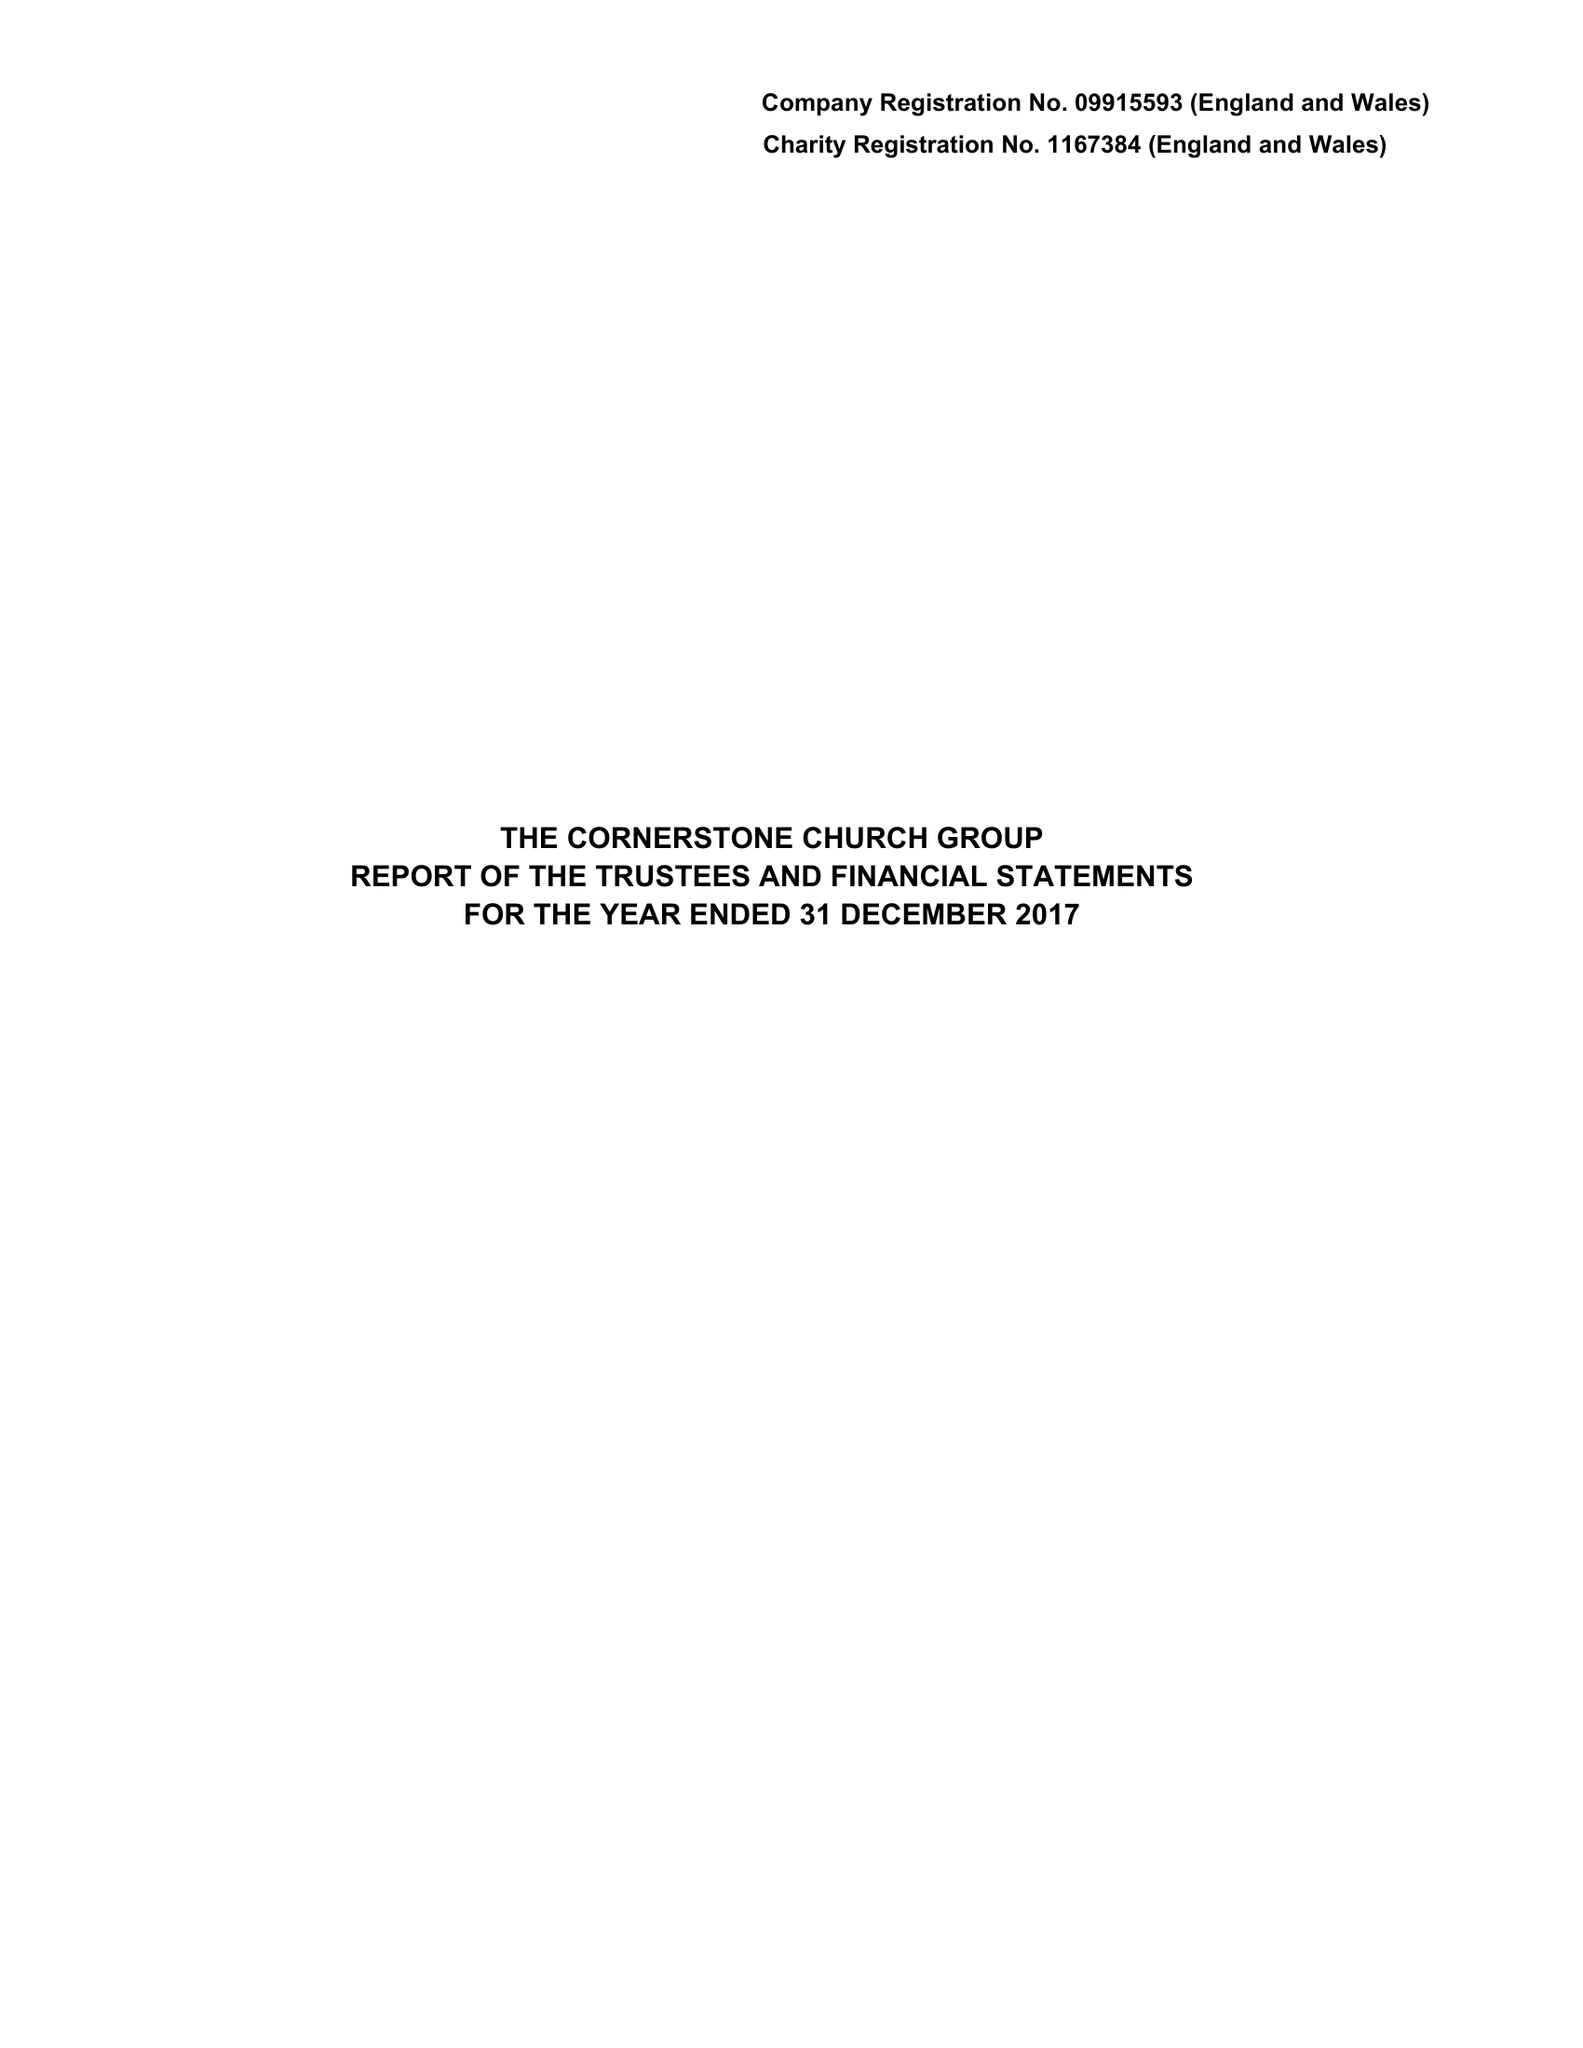What is the value for the income_annually_in_british_pounds?
Answer the question using a single word or phrase. 93747.00 